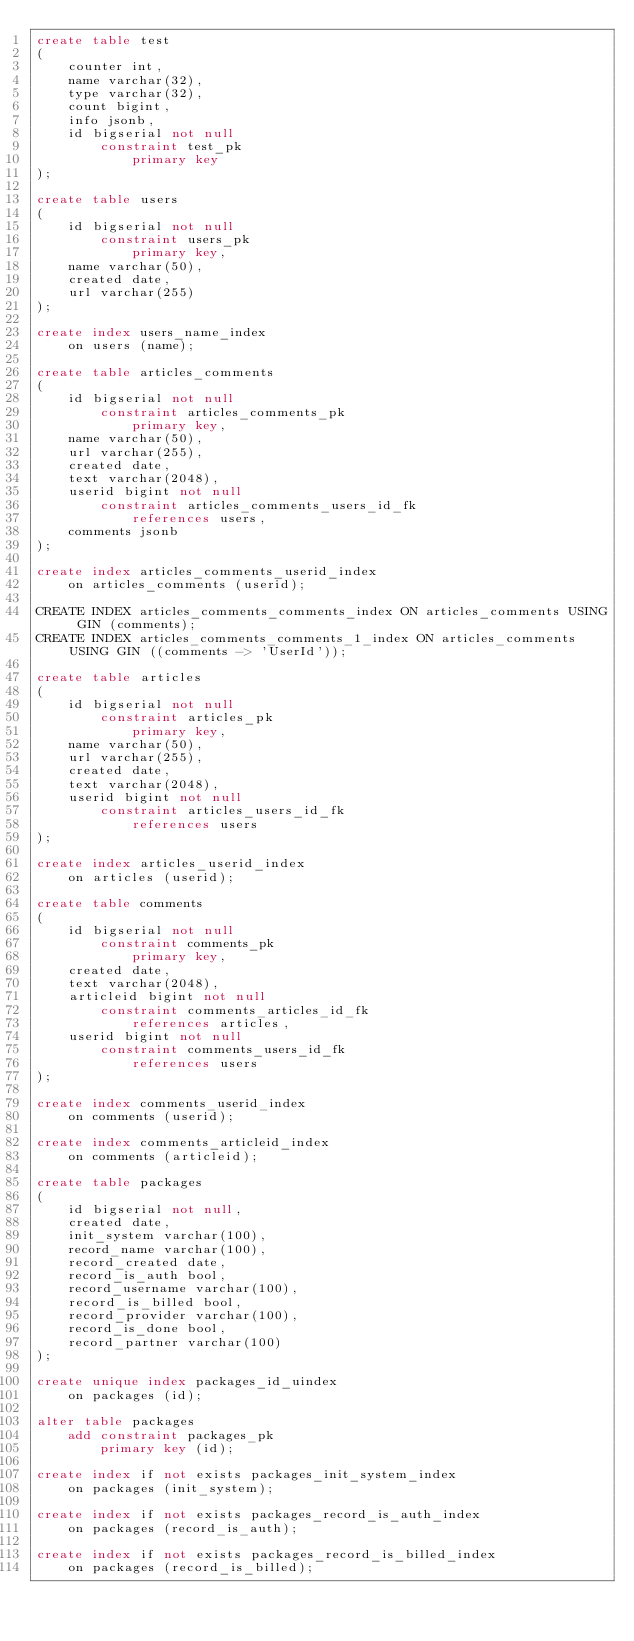Convert code to text. <code><loc_0><loc_0><loc_500><loc_500><_SQL_>create table test
(
	counter int,
	name varchar(32),
	type varchar(32),
	count bigint,
	info jsonb,
	id bigserial not null
		constraint test_pk
			primary key
);

create table users
(
	id bigserial not null
		constraint users_pk
			primary key,
	name varchar(50),
	created date,
	url varchar(255)
);

create index users_name_index
	on users (name);

create table articles_comments
(
	id bigserial not null
		constraint articles_comments_pk
			primary key,
	name varchar(50),
	url varchar(255),
	created date,
	text varchar(2048),
	userid bigint not null
		constraint articles_comments_users_id_fk
			references users,
	comments jsonb
);

create index articles_comments_userid_index
	on articles_comments (userid);

CREATE INDEX articles_comments_comments_index ON articles_comments USING GIN (comments);
CREATE INDEX articles_comments_comments_1_index ON articles_comments USING GIN ((comments -> 'UserId'));

create table articles
(
	id bigserial not null
		constraint articles_pk
			primary key,
	name varchar(50),
	url varchar(255),
	created date,
	text varchar(2048),
	userid bigint not null
		constraint articles_users_id_fk
			references users
);

create index articles_userid_index
	on articles (userid);

create table comments
(
	id bigserial not null
		constraint comments_pk
			primary key,
	created date,
	text varchar(2048),
	articleid bigint not null
		constraint comments_articles_id_fk
			references articles,
	userid bigint not null
		constraint comments_users_id_fk
			references users
);

create index comments_userid_index
	on comments (userid);

create index comments_articleid_index
	on comments (articleid);

create table packages
(
	id bigserial not null,
	created date,
	init_system varchar(100),
	record_name varchar(100),
	record_created date,
	record_is_auth bool,
	record_username varchar(100),
	record_is_billed bool,
	record_provider varchar(100),
	record_is_done bool,
	record_partner varchar(100)
);

create unique index packages_id_uindex
	on packages (id);

alter table packages
	add constraint packages_pk
		primary key (id);

create index if not exists packages_init_system_index
	on packages (init_system);

create index if not exists packages_record_is_auth_index
	on packages (record_is_auth);

create index if not exists packages_record_is_billed_index
	on packages (record_is_billed);
</code> 